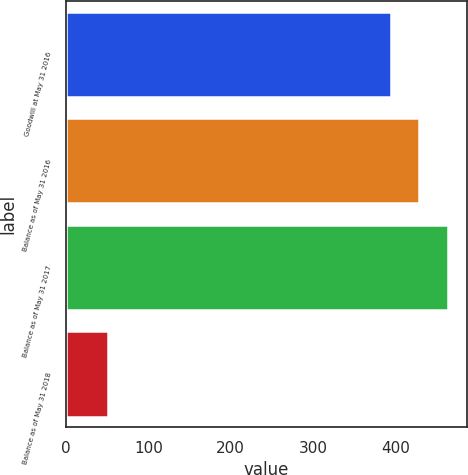<chart> <loc_0><loc_0><loc_500><loc_500><bar_chart><fcel>Goodwill at May 31 2016<fcel>Balance as of May 31 2016<fcel>Balance as of May 31 2017<fcel>Balance as of May 31 2018<nl><fcel>395<fcel>429.4<fcel>463.8<fcel>51<nl></chart> 